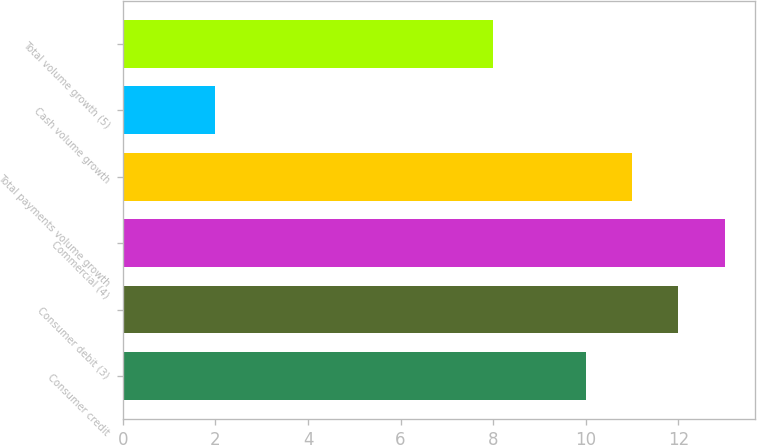<chart> <loc_0><loc_0><loc_500><loc_500><bar_chart><fcel>Consumer credit<fcel>Consumer debit (3)<fcel>Commercial (4)<fcel>Total payments volume growth<fcel>Cash volume growth<fcel>Total volume growth (5)<nl><fcel>10<fcel>12<fcel>13<fcel>11<fcel>2<fcel>8<nl></chart> 